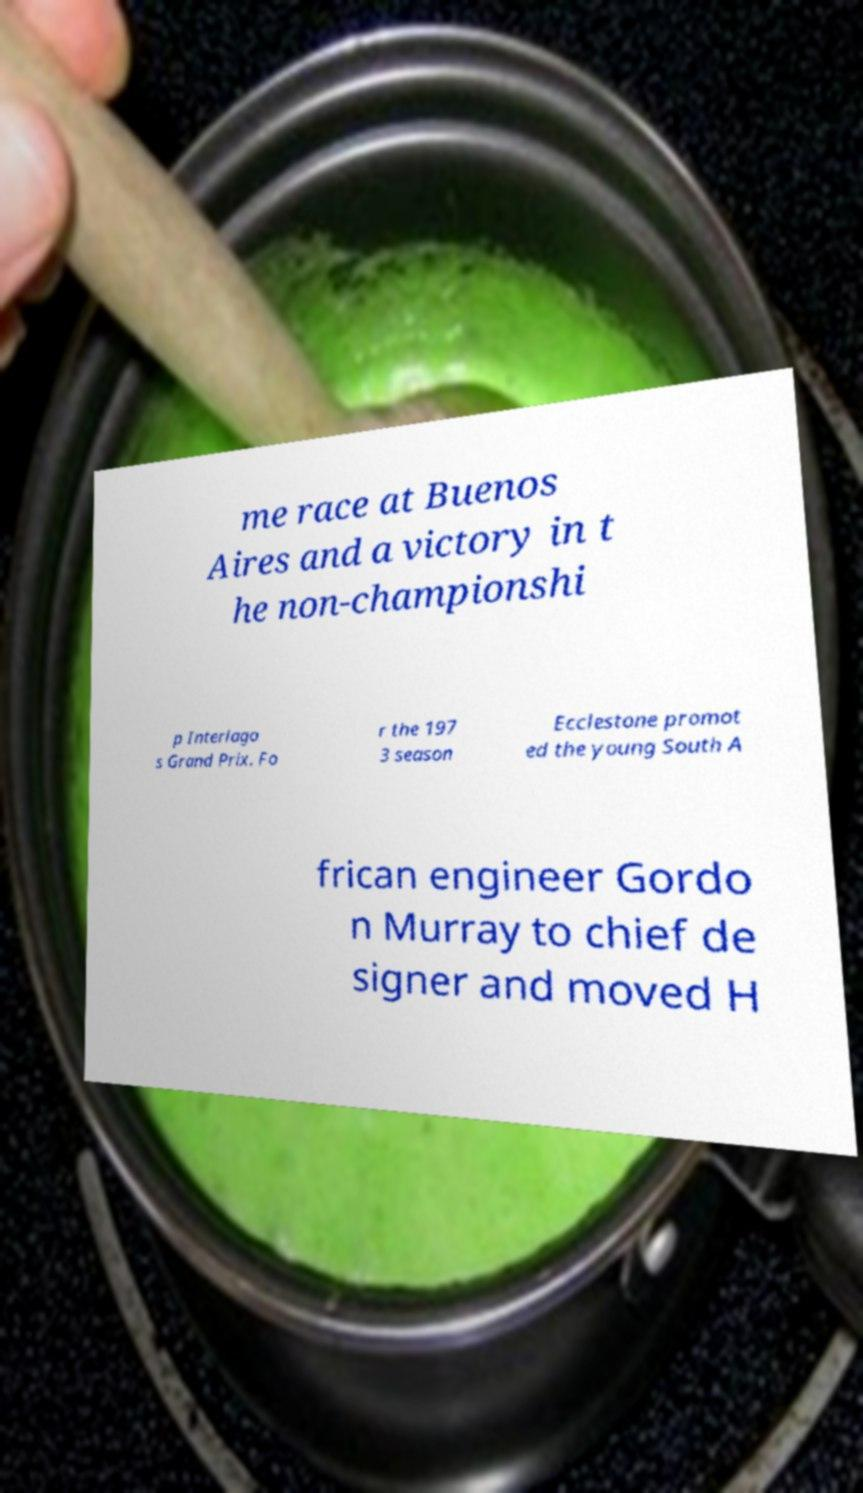Please read and relay the text visible in this image. What does it say? me race at Buenos Aires and a victory in t he non-championshi p Interlago s Grand Prix. Fo r the 197 3 season Ecclestone promot ed the young South A frican engineer Gordo n Murray to chief de signer and moved H 